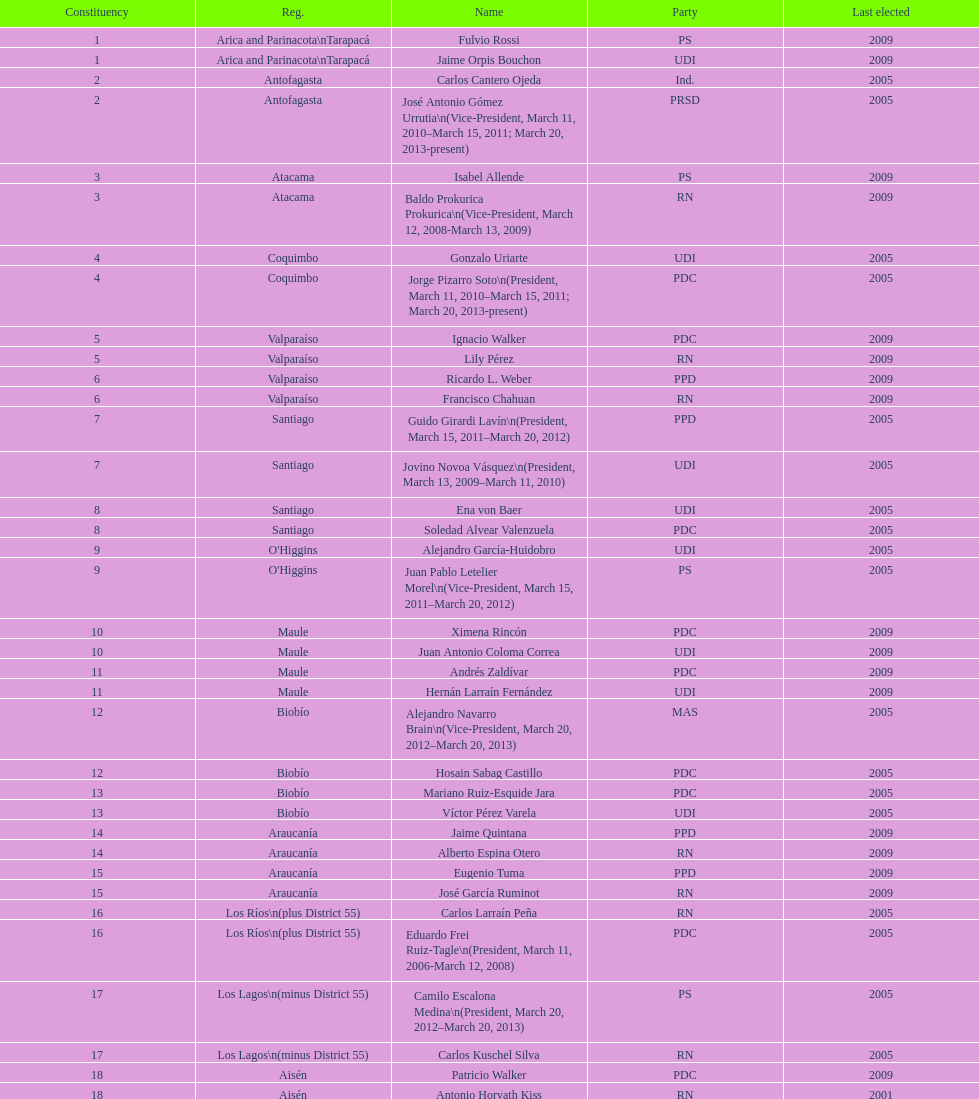Who was not last elected in either 2005 or 2009? Antonio Horvath Kiss. 